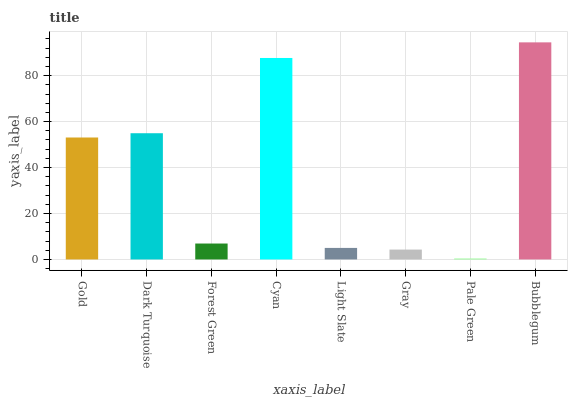Is Pale Green the minimum?
Answer yes or no. Yes. Is Bubblegum the maximum?
Answer yes or no. Yes. Is Dark Turquoise the minimum?
Answer yes or no. No. Is Dark Turquoise the maximum?
Answer yes or no. No. Is Dark Turquoise greater than Gold?
Answer yes or no. Yes. Is Gold less than Dark Turquoise?
Answer yes or no. Yes. Is Gold greater than Dark Turquoise?
Answer yes or no. No. Is Dark Turquoise less than Gold?
Answer yes or no. No. Is Gold the high median?
Answer yes or no. Yes. Is Forest Green the low median?
Answer yes or no. Yes. Is Gray the high median?
Answer yes or no. No. Is Light Slate the low median?
Answer yes or no. No. 